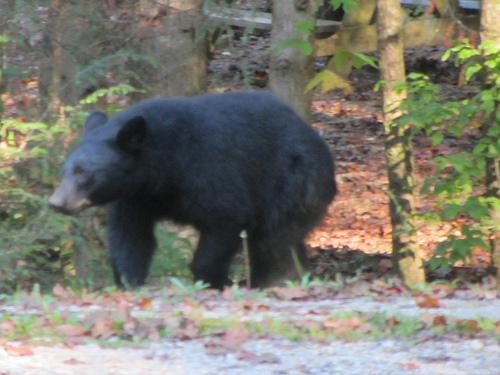Question: what animal is shown?
Choices:
A. Fox.
B. Deer.
C. Squirrel.
D. Bear.
Answer with the letter. Answer: D Question: who took the photo?
Choices:
A. Wildlife photographer.
B. Professional photographer.
C. Amatuer photographer.
D. Photography student.
Answer with the letter. Answer: A Question: where was the photo taken?
Choices:
A. Meadow.
B. Forest.
C. Beach.
D. Mountains.
Answer with the letter. Answer: B Question: why is the bear by itself?
Choices:
A. Isolated in a zoo.
B. Hunting.
C. Bears are not pack animals.
D. Left the cubs behind.
Answer with the letter. Answer: B 